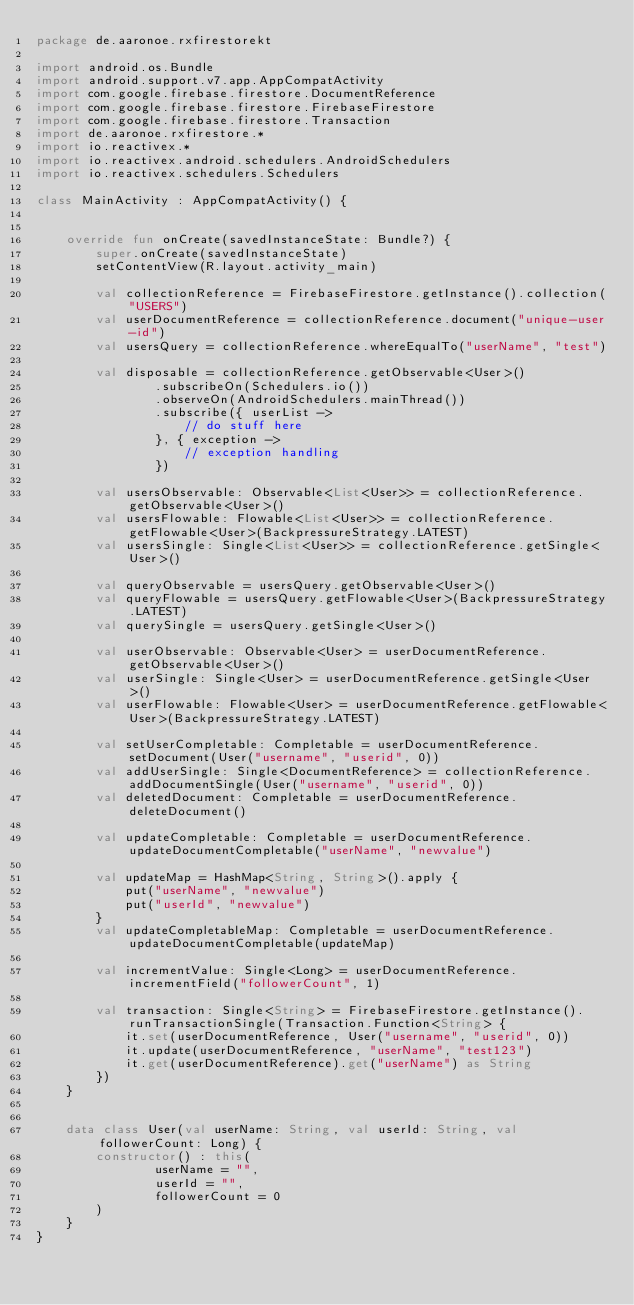Convert code to text. <code><loc_0><loc_0><loc_500><loc_500><_Kotlin_>package de.aaronoe.rxfirestorekt

import android.os.Bundle
import android.support.v7.app.AppCompatActivity
import com.google.firebase.firestore.DocumentReference
import com.google.firebase.firestore.FirebaseFirestore
import com.google.firebase.firestore.Transaction
import de.aaronoe.rxfirestore.*
import io.reactivex.*
import io.reactivex.android.schedulers.AndroidSchedulers
import io.reactivex.schedulers.Schedulers

class MainActivity : AppCompatActivity() {


    override fun onCreate(savedInstanceState: Bundle?) {
        super.onCreate(savedInstanceState)
        setContentView(R.layout.activity_main)

        val collectionReference = FirebaseFirestore.getInstance().collection("USERS")
        val userDocumentReference = collectionReference.document("unique-user-id")
        val usersQuery = collectionReference.whereEqualTo("userName", "test")

        val disposable = collectionReference.getObservable<User>()
                .subscribeOn(Schedulers.io())
                .observeOn(AndroidSchedulers.mainThread())
                .subscribe({ userList ->
                    // do stuff here
                }, { exception ->
                    // exception handling
                })

        val usersObservable: Observable<List<User>> = collectionReference.getObservable<User>()
        val usersFlowable: Flowable<List<User>> = collectionReference.getFlowable<User>(BackpressureStrategy.LATEST)
        val usersSingle: Single<List<User>> = collectionReference.getSingle<User>()

        val queryObservable = usersQuery.getObservable<User>()
        val queryFlowable = usersQuery.getFlowable<User>(BackpressureStrategy.LATEST)
        val querySingle = usersQuery.getSingle<User>()

        val userObservable: Observable<User> = userDocumentReference.getObservable<User>()
        val userSingle: Single<User> = userDocumentReference.getSingle<User>()
        val userFlowable: Flowable<User> = userDocumentReference.getFlowable<User>(BackpressureStrategy.LATEST)

        val setUserCompletable: Completable = userDocumentReference.setDocument(User("username", "userid", 0))
        val addUserSingle: Single<DocumentReference> = collectionReference.addDocumentSingle(User("username", "userid", 0))
        val deletedDocument: Completable = userDocumentReference.deleteDocument()

        val updateCompletable: Completable = userDocumentReference.updateDocumentCompletable("userName", "newvalue")

        val updateMap = HashMap<String, String>().apply {
            put("userName", "newvalue")
            put("userId", "newvalue")
        }
        val updateCompletableMap: Completable = userDocumentReference.updateDocumentCompletable(updateMap)

        val incrementValue: Single<Long> = userDocumentReference.incrementField("followerCount", 1)

        val transaction: Single<String> = FirebaseFirestore.getInstance().runTransactionSingle(Transaction.Function<String> {
            it.set(userDocumentReference, User("username", "userid", 0))
            it.update(userDocumentReference, "userName", "test123")
            it.get(userDocumentReference).get("userName") as String
        })
    }


    data class User(val userName: String, val userId: String, val followerCount: Long) {
        constructor() : this(
                userName = "",
                userId = "",
                followerCount = 0
        )
    }
}
</code> 